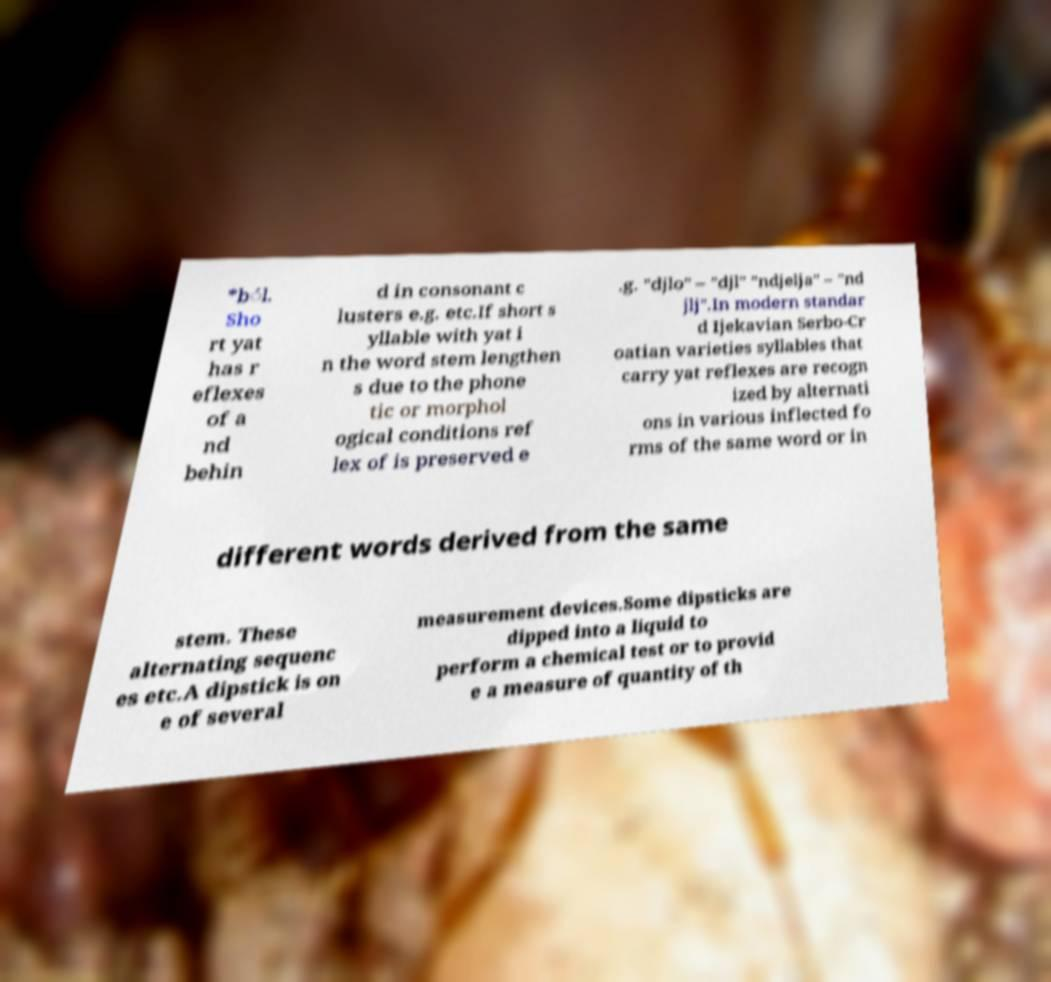I need the written content from this picture converted into text. Can you do that? *b́l. Sho rt yat has r eflexes of a nd behin d in consonant c lusters e.g. etc.If short s yllable with yat i n the word stem lengthen s due to the phone tic or morphol ogical conditions ref lex of is preserved e .g. "djlo" – "djl" "ndjelja" – "nd jlj".In modern standar d Ijekavian Serbo-Cr oatian varieties syllables that carry yat reflexes are recogn ized by alternati ons in various inflected fo rms of the same word or in different words derived from the same stem. These alternating sequenc es etc.A dipstick is on e of several measurement devices.Some dipsticks are dipped into a liquid to perform a chemical test or to provid e a measure of quantity of th 